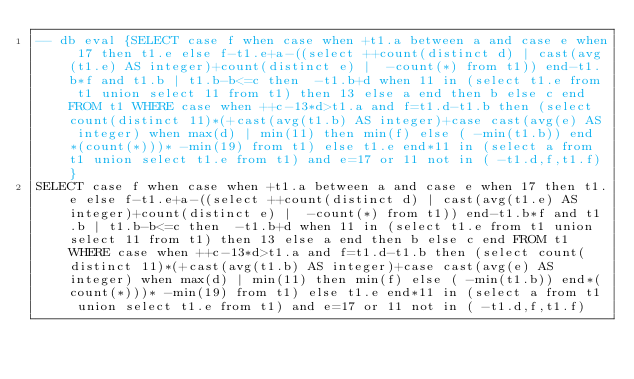Convert code to text. <code><loc_0><loc_0><loc_500><loc_500><_SQL_>-- db eval {SELECT case f when case when +t1.a between a and case e when 17 then t1.e else f-t1.e+a-((select ++count(distinct d) | cast(avg(t1.e) AS integer)+count(distinct e) |  -count(*) from t1)) end-t1.b*f and t1.b | t1.b-b<=c then  -t1.b+d when 11 in (select t1.e from t1 union select 11 from t1) then 13 else a end then b else c end FROM t1 WHERE case when ++c-13*d>t1.a and f=t1.d-t1.b then (select count(distinct 11)*(+cast(avg(t1.b) AS integer)+case cast(avg(e) AS integer) when max(d) | min(11) then min(f) else ( -min(t1.b)) end*(count(*)))* -min(19) from t1) else t1.e end*11 in (select a from t1 union select t1.e from t1) and e=17 or 11 not in ( -t1.d,f,t1.f)}
SELECT case f when case when +t1.a between a and case e when 17 then t1.e else f-t1.e+a-((select ++count(distinct d) | cast(avg(t1.e) AS integer)+count(distinct e) |  -count(*) from t1)) end-t1.b*f and t1.b | t1.b-b<=c then  -t1.b+d when 11 in (select t1.e from t1 union select 11 from t1) then 13 else a end then b else c end FROM t1 WHERE case when ++c-13*d>t1.a and f=t1.d-t1.b then (select count(distinct 11)*(+cast(avg(t1.b) AS integer)+case cast(avg(e) AS integer) when max(d) | min(11) then min(f) else ( -min(t1.b)) end*(count(*)))* -min(19) from t1) else t1.e end*11 in (select a from t1 union select t1.e from t1) and e=17 or 11 not in ( -t1.d,f,t1.f)</code> 